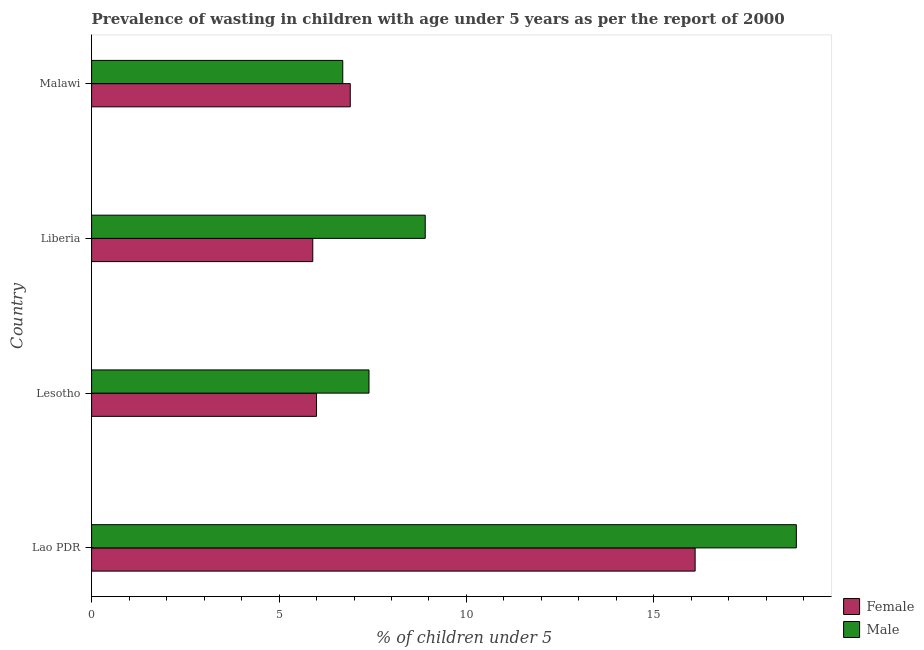How many different coloured bars are there?
Ensure brevity in your answer.  2. Are the number of bars per tick equal to the number of legend labels?
Provide a short and direct response. Yes. How many bars are there on the 4th tick from the top?
Make the answer very short. 2. How many bars are there on the 2nd tick from the bottom?
Provide a succinct answer. 2. What is the label of the 4th group of bars from the top?
Provide a succinct answer. Lao PDR. In how many cases, is the number of bars for a given country not equal to the number of legend labels?
Your response must be concise. 0. What is the percentage of undernourished male children in Malawi?
Your answer should be compact. 6.7. Across all countries, what is the maximum percentage of undernourished male children?
Provide a short and direct response. 18.8. Across all countries, what is the minimum percentage of undernourished male children?
Offer a terse response. 6.7. In which country was the percentage of undernourished male children maximum?
Ensure brevity in your answer.  Lao PDR. In which country was the percentage of undernourished female children minimum?
Make the answer very short. Liberia. What is the total percentage of undernourished female children in the graph?
Your response must be concise. 34.9. What is the difference between the percentage of undernourished female children in Lao PDR and the percentage of undernourished male children in Liberia?
Your answer should be very brief. 7.2. What is the average percentage of undernourished female children per country?
Make the answer very short. 8.72. In how many countries, is the percentage of undernourished female children greater than 16 %?
Keep it short and to the point. 1. Is the percentage of undernourished female children in Lao PDR less than that in Liberia?
Your response must be concise. No. Is the difference between the percentage of undernourished female children in Lao PDR and Malawi greater than the difference between the percentage of undernourished male children in Lao PDR and Malawi?
Provide a short and direct response. No. What is the difference between the highest and the second highest percentage of undernourished female children?
Ensure brevity in your answer.  9.2. What is the difference between the highest and the lowest percentage of undernourished male children?
Make the answer very short. 12.1. Is the sum of the percentage of undernourished male children in Liberia and Malawi greater than the maximum percentage of undernourished female children across all countries?
Offer a terse response. No. What does the 2nd bar from the bottom in Malawi represents?
Offer a terse response. Male. How many bars are there?
Your response must be concise. 8. What is the difference between two consecutive major ticks on the X-axis?
Your answer should be compact. 5. Does the graph contain any zero values?
Offer a very short reply. No. What is the title of the graph?
Provide a short and direct response. Prevalence of wasting in children with age under 5 years as per the report of 2000. What is the label or title of the X-axis?
Your answer should be compact.  % of children under 5. What is the  % of children under 5 of Female in Lao PDR?
Your response must be concise. 16.1. What is the  % of children under 5 of Male in Lao PDR?
Ensure brevity in your answer.  18.8. What is the  % of children under 5 in Female in Lesotho?
Ensure brevity in your answer.  6. What is the  % of children under 5 in Male in Lesotho?
Offer a terse response. 7.4. What is the  % of children under 5 of Female in Liberia?
Keep it short and to the point. 5.9. What is the  % of children under 5 in Male in Liberia?
Provide a succinct answer. 8.9. What is the  % of children under 5 of Female in Malawi?
Offer a terse response. 6.9. What is the  % of children under 5 of Male in Malawi?
Give a very brief answer. 6.7. Across all countries, what is the maximum  % of children under 5 in Female?
Provide a succinct answer. 16.1. Across all countries, what is the maximum  % of children under 5 in Male?
Offer a terse response. 18.8. Across all countries, what is the minimum  % of children under 5 of Female?
Provide a succinct answer. 5.9. Across all countries, what is the minimum  % of children under 5 in Male?
Provide a succinct answer. 6.7. What is the total  % of children under 5 of Female in the graph?
Your response must be concise. 34.9. What is the total  % of children under 5 in Male in the graph?
Your answer should be compact. 41.8. What is the difference between the  % of children under 5 in Female in Lao PDR and that in Lesotho?
Ensure brevity in your answer.  10.1. What is the difference between the  % of children under 5 in Male in Lao PDR and that in Lesotho?
Keep it short and to the point. 11.4. What is the difference between the  % of children under 5 in Female in Lao PDR and that in Liberia?
Provide a succinct answer. 10.2. What is the difference between the  % of children under 5 in Female in Lao PDR and that in Malawi?
Offer a very short reply. 9.2. What is the difference between the  % of children under 5 of Male in Lao PDR and that in Malawi?
Keep it short and to the point. 12.1. What is the difference between the  % of children under 5 in Female in Lesotho and that in Liberia?
Ensure brevity in your answer.  0.1. What is the difference between the  % of children under 5 in Male in Lesotho and that in Liberia?
Offer a very short reply. -1.5. What is the difference between the  % of children under 5 in Female in Lao PDR and the  % of children under 5 in Male in Liberia?
Provide a succinct answer. 7.2. What is the difference between the  % of children under 5 of Female in Lao PDR and the  % of children under 5 of Male in Malawi?
Ensure brevity in your answer.  9.4. What is the average  % of children under 5 in Female per country?
Offer a terse response. 8.72. What is the average  % of children under 5 in Male per country?
Your response must be concise. 10.45. What is the difference between the  % of children under 5 in Female and  % of children under 5 in Male in Lao PDR?
Give a very brief answer. -2.7. What is the difference between the  % of children under 5 of Female and  % of children under 5 of Male in Malawi?
Provide a short and direct response. 0.2. What is the ratio of the  % of children under 5 in Female in Lao PDR to that in Lesotho?
Provide a short and direct response. 2.68. What is the ratio of the  % of children under 5 in Male in Lao PDR to that in Lesotho?
Make the answer very short. 2.54. What is the ratio of the  % of children under 5 of Female in Lao PDR to that in Liberia?
Give a very brief answer. 2.73. What is the ratio of the  % of children under 5 of Male in Lao PDR to that in Liberia?
Your answer should be very brief. 2.11. What is the ratio of the  % of children under 5 of Female in Lao PDR to that in Malawi?
Give a very brief answer. 2.33. What is the ratio of the  % of children under 5 of Male in Lao PDR to that in Malawi?
Offer a very short reply. 2.81. What is the ratio of the  % of children under 5 of Female in Lesotho to that in Liberia?
Give a very brief answer. 1.02. What is the ratio of the  % of children under 5 of Male in Lesotho to that in Liberia?
Ensure brevity in your answer.  0.83. What is the ratio of the  % of children under 5 of Female in Lesotho to that in Malawi?
Keep it short and to the point. 0.87. What is the ratio of the  % of children under 5 of Male in Lesotho to that in Malawi?
Offer a very short reply. 1.1. What is the ratio of the  % of children under 5 of Female in Liberia to that in Malawi?
Your answer should be compact. 0.86. What is the ratio of the  % of children under 5 in Male in Liberia to that in Malawi?
Offer a very short reply. 1.33. What is the difference between the highest and the second highest  % of children under 5 of Female?
Make the answer very short. 9.2. What is the difference between the highest and the second highest  % of children under 5 of Male?
Ensure brevity in your answer.  9.9. What is the difference between the highest and the lowest  % of children under 5 in Female?
Your answer should be compact. 10.2. 